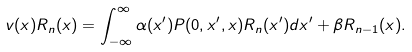Convert formula to latex. <formula><loc_0><loc_0><loc_500><loc_500>v ( x ) R _ { n } ( x ) = \int _ { - \infty } ^ { \infty } \alpha ( x ^ { \prime } ) P ( 0 , x ^ { \prime } , x ) R _ { n } ( x ^ { \prime } ) d x ^ { \prime } + \beta R _ { n - 1 } ( x ) .</formula> 